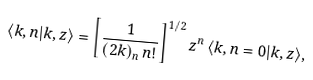<formula> <loc_0><loc_0><loc_500><loc_500>\langle k , n | k , z \rangle = \left [ \frac { 1 } { ( 2 k ) _ { n } \, n ! } \right ] ^ { 1 / 2 } z ^ { n } \, \langle k , n = 0 | k , z \rangle ,</formula> 